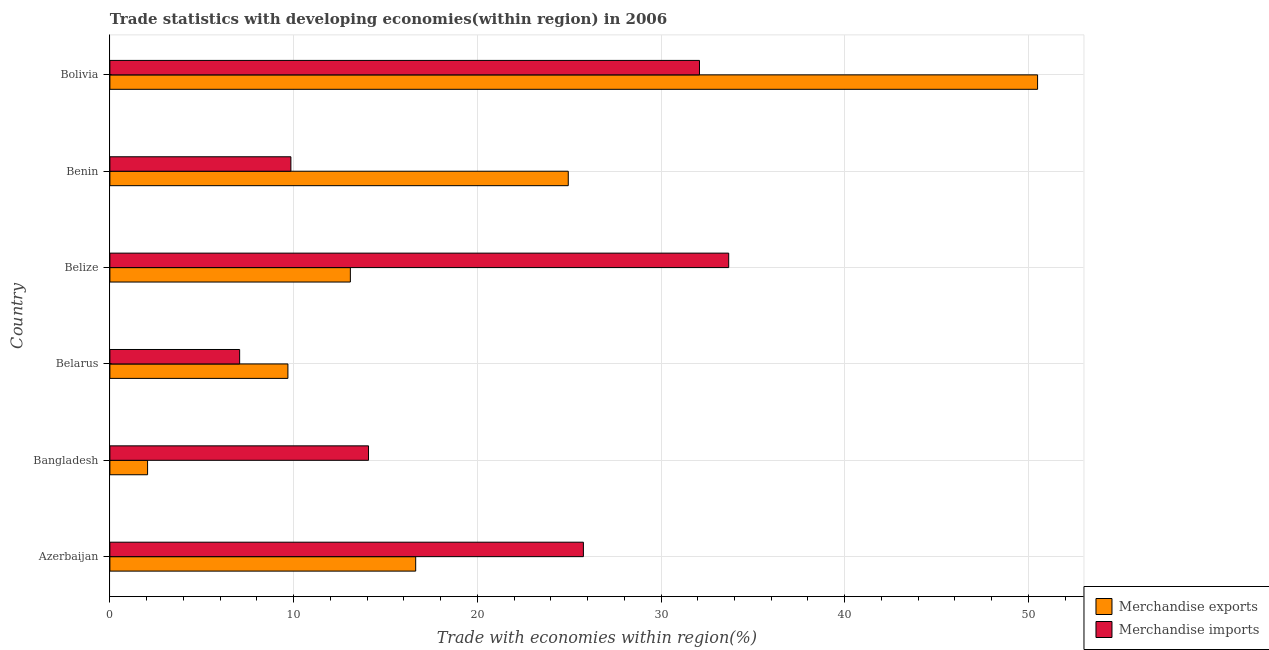How many different coloured bars are there?
Make the answer very short. 2. How many bars are there on the 3rd tick from the bottom?
Give a very brief answer. 2. In how many cases, is the number of bars for a given country not equal to the number of legend labels?
Make the answer very short. 0. What is the merchandise exports in Benin?
Keep it short and to the point. 24.95. Across all countries, what is the maximum merchandise exports?
Provide a succinct answer. 50.5. Across all countries, what is the minimum merchandise imports?
Provide a succinct answer. 7.06. In which country was the merchandise imports minimum?
Keep it short and to the point. Belarus. What is the total merchandise exports in the graph?
Ensure brevity in your answer.  116.92. What is the difference between the merchandise imports in Belize and that in Benin?
Your answer should be compact. 23.83. What is the difference between the merchandise imports in Bolivia and the merchandise exports in Belarus?
Offer a very short reply. 22.4. What is the average merchandise exports per country?
Your answer should be compact. 19.49. What is the difference between the merchandise exports and merchandise imports in Azerbaijan?
Your response must be concise. -9.13. In how many countries, is the merchandise imports greater than 22 %?
Give a very brief answer. 3. What is the ratio of the merchandise exports in Azerbaijan to that in Bangladesh?
Ensure brevity in your answer.  8.11. Is the merchandise imports in Bangladesh less than that in Benin?
Give a very brief answer. No. What is the difference between the highest and the second highest merchandise imports?
Your answer should be compact. 1.59. What is the difference between the highest and the lowest merchandise imports?
Give a very brief answer. 26.62. In how many countries, is the merchandise imports greater than the average merchandise imports taken over all countries?
Your answer should be very brief. 3. Is the sum of the merchandise exports in Azerbaijan and Bangladesh greater than the maximum merchandise imports across all countries?
Give a very brief answer. No. What does the 1st bar from the top in Bolivia represents?
Your answer should be very brief. Merchandise imports. How many countries are there in the graph?
Your answer should be compact. 6. What is the difference between two consecutive major ticks on the X-axis?
Ensure brevity in your answer.  10. How many legend labels are there?
Your answer should be compact. 2. What is the title of the graph?
Provide a short and direct response. Trade statistics with developing economies(within region) in 2006. Does "ODA received" appear as one of the legend labels in the graph?
Offer a very short reply. No. What is the label or title of the X-axis?
Keep it short and to the point. Trade with economies within region(%). What is the Trade with economies within region(%) of Merchandise exports in Azerbaijan?
Your response must be concise. 16.65. What is the Trade with economies within region(%) in Merchandise imports in Azerbaijan?
Your response must be concise. 25.77. What is the Trade with economies within region(%) of Merchandise exports in Bangladesh?
Give a very brief answer. 2.05. What is the Trade with economies within region(%) of Merchandise imports in Bangladesh?
Your response must be concise. 14.08. What is the Trade with economies within region(%) of Merchandise exports in Belarus?
Offer a terse response. 9.69. What is the Trade with economies within region(%) in Merchandise imports in Belarus?
Offer a terse response. 7.06. What is the Trade with economies within region(%) of Merchandise exports in Belize?
Keep it short and to the point. 13.09. What is the Trade with economies within region(%) of Merchandise imports in Belize?
Make the answer very short. 33.68. What is the Trade with economies within region(%) of Merchandise exports in Benin?
Your answer should be compact. 24.95. What is the Trade with economies within region(%) in Merchandise imports in Benin?
Provide a short and direct response. 9.85. What is the Trade with economies within region(%) of Merchandise exports in Bolivia?
Give a very brief answer. 50.5. What is the Trade with economies within region(%) in Merchandise imports in Bolivia?
Provide a short and direct response. 32.09. Across all countries, what is the maximum Trade with economies within region(%) in Merchandise exports?
Your response must be concise. 50.5. Across all countries, what is the maximum Trade with economies within region(%) of Merchandise imports?
Provide a succinct answer. 33.68. Across all countries, what is the minimum Trade with economies within region(%) in Merchandise exports?
Make the answer very short. 2.05. Across all countries, what is the minimum Trade with economies within region(%) of Merchandise imports?
Your answer should be very brief. 7.06. What is the total Trade with economies within region(%) in Merchandise exports in the graph?
Offer a very short reply. 116.92. What is the total Trade with economies within region(%) of Merchandise imports in the graph?
Offer a terse response. 122.55. What is the difference between the Trade with economies within region(%) of Merchandise exports in Azerbaijan and that in Bangladesh?
Keep it short and to the point. 14.59. What is the difference between the Trade with economies within region(%) in Merchandise imports in Azerbaijan and that in Bangladesh?
Provide a short and direct response. 11.7. What is the difference between the Trade with economies within region(%) in Merchandise exports in Azerbaijan and that in Belarus?
Your answer should be compact. 6.96. What is the difference between the Trade with economies within region(%) of Merchandise imports in Azerbaijan and that in Belarus?
Offer a terse response. 18.71. What is the difference between the Trade with economies within region(%) in Merchandise exports in Azerbaijan and that in Belize?
Provide a succinct answer. 3.56. What is the difference between the Trade with economies within region(%) in Merchandise imports in Azerbaijan and that in Belize?
Offer a terse response. -7.91. What is the difference between the Trade with economies within region(%) of Merchandise exports in Azerbaijan and that in Benin?
Make the answer very short. -8.31. What is the difference between the Trade with economies within region(%) in Merchandise imports in Azerbaijan and that in Benin?
Offer a very short reply. 15.92. What is the difference between the Trade with economies within region(%) in Merchandise exports in Azerbaijan and that in Bolivia?
Your answer should be very brief. -33.85. What is the difference between the Trade with economies within region(%) in Merchandise imports in Azerbaijan and that in Bolivia?
Make the answer very short. -6.32. What is the difference between the Trade with economies within region(%) in Merchandise exports in Bangladesh and that in Belarus?
Give a very brief answer. -7.64. What is the difference between the Trade with economies within region(%) in Merchandise imports in Bangladesh and that in Belarus?
Make the answer very short. 7.01. What is the difference between the Trade with economies within region(%) in Merchandise exports in Bangladesh and that in Belize?
Keep it short and to the point. -11.04. What is the difference between the Trade with economies within region(%) of Merchandise imports in Bangladesh and that in Belize?
Your response must be concise. -19.61. What is the difference between the Trade with economies within region(%) of Merchandise exports in Bangladesh and that in Benin?
Offer a very short reply. -22.9. What is the difference between the Trade with economies within region(%) in Merchandise imports in Bangladesh and that in Benin?
Provide a short and direct response. 4.23. What is the difference between the Trade with economies within region(%) in Merchandise exports in Bangladesh and that in Bolivia?
Provide a short and direct response. -48.45. What is the difference between the Trade with economies within region(%) of Merchandise imports in Bangladesh and that in Bolivia?
Your answer should be very brief. -18.02. What is the difference between the Trade with economies within region(%) of Merchandise exports in Belarus and that in Belize?
Keep it short and to the point. -3.4. What is the difference between the Trade with economies within region(%) of Merchandise imports in Belarus and that in Belize?
Provide a short and direct response. -26.62. What is the difference between the Trade with economies within region(%) in Merchandise exports in Belarus and that in Benin?
Offer a very short reply. -15.26. What is the difference between the Trade with economies within region(%) of Merchandise imports in Belarus and that in Benin?
Your response must be concise. -2.79. What is the difference between the Trade with economies within region(%) of Merchandise exports in Belarus and that in Bolivia?
Ensure brevity in your answer.  -40.81. What is the difference between the Trade with economies within region(%) in Merchandise imports in Belarus and that in Bolivia?
Give a very brief answer. -25.03. What is the difference between the Trade with economies within region(%) in Merchandise exports in Belize and that in Benin?
Ensure brevity in your answer.  -11.86. What is the difference between the Trade with economies within region(%) of Merchandise imports in Belize and that in Benin?
Provide a short and direct response. 23.83. What is the difference between the Trade with economies within region(%) in Merchandise exports in Belize and that in Bolivia?
Keep it short and to the point. -37.41. What is the difference between the Trade with economies within region(%) of Merchandise imports in Belize and that in Bolivia?
Offer a terse response. 1.59. What is the difference between the Trade with economies within region(%) in Merchandise exports in Benin and that in Bolivia?
Keep it short and to the point. -25.55. What is the difference between the Trade with economies within region(%) of Merchandise imports in Benin and that in Bolivia?
Your response must be concise. -22.24. What is the difference between the Trade with economies within region(%) of Merchandise exports in Azerbaijan and the Trade with economies within region(%) of Merchandise imports in Bangladesh?
Keep it short and to the point. 2.57. What is the difference between the Trade with economies within region(%) in Merchandise exports in Azerbaijan and the Trade with economies within region(%) in Merchandise imports in Belarus?
Your answer should be compact. 9.58. What is the difference between the Trade with economies within region(%) of Merchandise exports in Azerbaijan and the Trade with economies within region(%) of Merchandise imports in Belize?
Offer a terse response. -17.04. What is the difference between the Trade with economies within region(%) of Merchandise exports in Azerbaijan and the Trade with economies within region(%) of Merchandise imports in Benin?
Keep it short and to the point. 6.79. What is the difference between the Trade with economies within region(%) in Merchandise exports in Azerbaijan and the Trade with economies within region(%) in Merchandise imports in Bolivia?
Provide a short and direct response. -15.45. What is the difference between the Trade with economies within region(%) of Merchandise exports in Bangladesh and the Trade with economies within region(%) of Merchandise imports in Belarus?
Make the answer very short. -5.01. What is the difference between the Trade with economies within region(%) in Merchandise exports in Bangladesh and the Trade with economies within region(%) in Merchandise imports in Belize?
Make the answer very short. -31.63. What is the difference between the Trade with economies within region(%) of Merchandise exports in Bangladesh and the Trade with economies within region(%) of Merchandise imports in Benin?
Offer a terse response. -7.8. What is the difference between the Trade with economies within region(%) of Merchandise exports in Bangladesh and the Trade with economies within region(%) of Merchandise imports in Bolivia?
Ensure brevity in your answer.  -30.04. What is the difference between the Trade with economies within region(%) of Merchandise exports in Belarus and the Trade with economies within region(%) of Merchandise imports in Belize?
Your answer should be compact. -23.99. What is the difference between the Trade with economies within region(%) in Merchandise exports in Belarus and the Trade with economies within region(%) in Merchandise imports in Benin?
Provide a succinct answer. -0.16. What is the difference between the Trade with economies within region(%) in Merchandise exports in Belarus and the Trade with economies within region(%) in Merchandise imports in Bolivia?
Offer a very short reply. -22.4. What is the difference between the Trade with economies within region(%) in Merchandise exports in Belize and the Trade with economies within region(%) in Merchandise imports in Benin?
Offer a very short reply. 3.24. What is the difference between the Trade with economies within region(%) of Merchandise exports in Belize and the Trade with economies within region(%) of Merchandise imports in Bolivia?
Your answer should be compact. -19. What is the difference between the Trade with economies within region(%) of Merchandise exports in Benin and the Trade with economies within region(%) of Merchandise imports in Bolivia?
Offer a terse response. -7.14. What is the average Trade with economies within region(%) in Merchandise exports per country?
Provide a short and direct response. 19.49. What is the average Trade with economies within region(%) in Merchandise imports per country?
Keep it short and to the point. 20.42. What is the difference between the Trade with economies within region(%) in Merchandise exports and Trade with economies within region(%) in Merchandise imports in Azerbaijan?
Ensure brevity in your answer.  -9.13. What is the difference between the Trade with economies within region(%) of Merchandise exports and Trade with economies within region(%) of Merchandise imports in Bangladesh?
Ensure brevity in your answer.  -12.03. What is the difference between the Trade with economies within region(%) of Merchandise exports and Trade with economies within region(%) of Merchandise imports in Belarus?
Your answer should be compact. 2.63. What is the difference between the Trade with economies within region(%) in Merchandise exports and Trade with economies within region(%) in Merchandise imports in Belize?
Provide a short and direct response. -20.59. What is the difference between the Trade with economies within region(%) in Merchandise exports and Trade with economies within region(%) in Merchandise imports in Benin?
Keep it short and to the point. 15.1. What is the difference between the Trade with economies within region(%) in Merchandise exports and Trade with economies within region(%) in Merchandise imports in Bolivia?
Provide a short and direct response. 18.4. What is the ratio of the Trade with economies within region(%) of Merchandise exports in Azerbaijan to that in Bangladesh?
Provide a short and direct response. 8.11. What is the ratio of the Trade with economies within region(%) of Merchandise imports in Azerbaijan to that in Bangladesh?
Keep it short and to the point. 1.83. What is the ratio of the Trade with economies within region(%) of Merchandise exports in Azerbaijan to that in Belarus?
Offer a very short reply. 1.72. What is the ratio of the Trade with economies within region(%) of Merchandise imports in Azerbaijan to that in Belarus?
Your response must be concise. 3.65. What is the ratio of the Trade with economies within region(%) of Merchandise exports in Azerbaijan to that in Belize?
Your answer should be compact. 1.27. What is the ratio of the Trade with economies within region(%) in Merchandise imports in Azerbaijan to that in Belize?
Offer a terse response. 0.77. What is the ratio of the Trade with economies within region(%) of Merchandise exports in Azerbaijan to that in Benin?
Offer a terse response. 0.67. What is the ratio of the Trade with economies within region(%) in Merchandise imports in Azerbaijan to that in Benin?
Provide a succinct answer. 2.62. What is the ratio of the Trade with economies within region(%) of Merchandise exports in Azerbaijan to that in Bolivia?
Offer a very short reply. 0.33. What is the ratio of the Trade with economies within region(%) in Merchandise imports in Azerbaijan to that in Bolivia?
Your response must be concise. 0.8. What is the ratio of the Trade with economies within region(%) of Merchandise exports in Bangladesh to that in Belarus?
Provide a succinct answer. 0.21. What is the ratio of the Trade with economies within region(%) of Merchandise imports in Bangladesh to that in Belarus?
Your response must be concise. 1.99. What is the ratio of the Trade with economies within region(%) in Merchandise exports in Bangladesh to that in Belize?
Your response must be concise. 0.16. What is the ratio of the Trade with economies within region(%) in Merchandise imports in Bangladesh to that in Belize?
Provide a succinct answer. 0.42. What is the ratio of the Trade with economies within region(%) of Merchandise exports in Bangladesh to that in Benin?
Offer a very short reply. 0.08. What is the ratio of the Trade with economies within region(%) of Merchandise imports in Bangladesh to that in Benin?
Your response must be concise. 1.43. What is the ratio of the Trade with economies within region(%) in Merchandise exports in Bangladesh to that in Bolivia?
Offer a terse response. 0.04. What is the ratio of the Trade with economies within region(%) of Merchandise imports in Bangladesh to that in Bolivia?
Your answer should be very brief. 0.44. What is the ratio of the Trade with economies within region(%) in Merchandise exports in Belarus to that in Belize?
Provide a succinct answer. 0.74. What is the ratio of the Trade with economies within region(%) in Merchandise imports in Belarus to that in Belize?
Ensure brevity in your answer.  0.21. What is the ratio of the Trade with economies within region(%) in Merchandise exports in Belarus to that in Benin?
Ensure brevity in your answer.  0.39. What is the ratio of the Trade with economies within region(%) in Merchandise imports in Belarus to that in Benin?
Offer a terse response. 0.72. What is the ratio of the Trade with economies within region(%) of Merchandise exports in Belarus to that in Bolivia?
Offer a very short reply. 0.19. What is the ratio of the Trade with economies within region(%) in Merchandise imports in Belarus to that in Bolivia?
Provide a short and direct response. 0.22. What is the ratio of the Trade with economies within region(%) in Merchandise exports in Belize to that in Benin?
Offer a very short reply. 0.52. What is the ratio of the Trade with economies within region(%) in Merchandise imports in Belize to that in Benin?
Offer a terse response. 3.42. What is the ratio of the Trade with economies within region(%) in Merchandise exports in Belize to that in Bolivia?
Make the answer very short. 0.26. What is the ratio of the Trade with economies within region(%) in Merchandise imports in Belize to that in Bolivia?
Your response must be concise. 1.05. What is the ratio of the Trade with economies within region(%) of Merchandise exports in Benin to that in Bolivia?
Offer a very short reply. 0.49. What is the ratio of the Trade with economies within region(%) in Merchandise imports in Benin to that in Bolivia?
Your answer should be compact. 0.31. What is the difference between the highest and the second highest Trade with economies within region(%) in Merchandise exports?
Offer a very short reply. 25.55. What is the difference between the highest and the second highest Trade with economies within region(%) of Merchandise imports?
Give a very brief answer. 1.59. What is the difference between the highest and the lowest Trade with economies within region(%) of Merchandise exports?
Offer a very short reply. 48.45. What is the difference between the highest and the lowest Trade with economies within region(%) in Merchandise imports?
Provide a succinct answer. 26.62. 